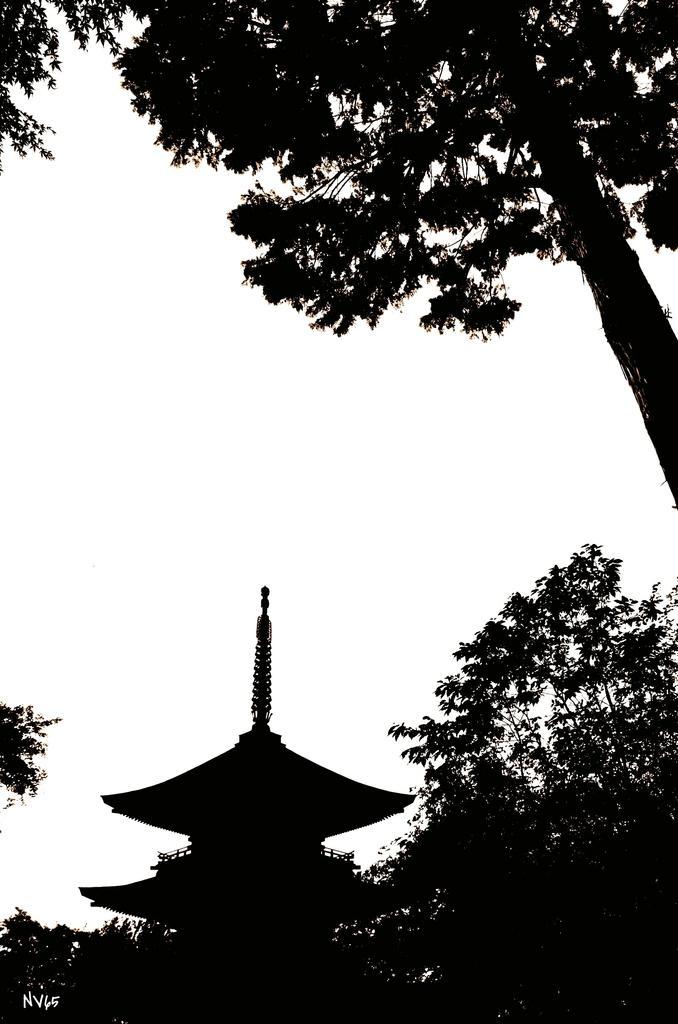How would you summarize this image in a sentence or two? This is a black and white image. In this we can see a house and trees. 